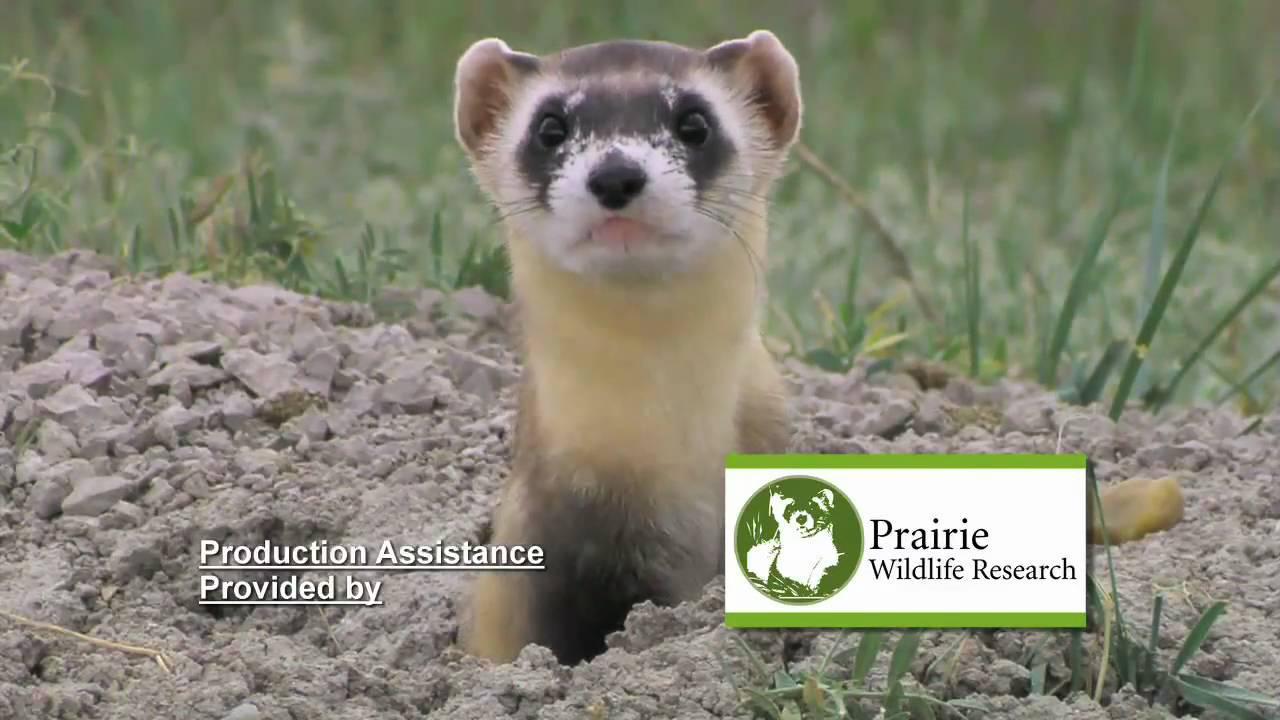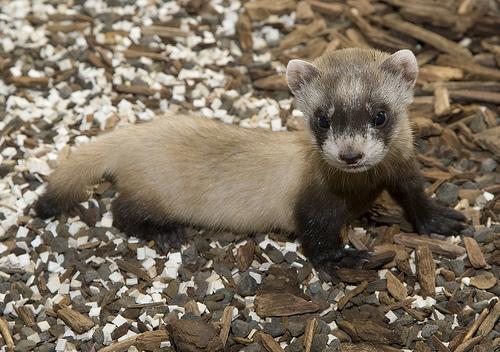The first image is the image on the left, the second image is the image on the right. For the images shown, is this caption "There are no more than three ferrets" true? Answer yes or no. Yes. The first image is the image on the left, the second image is the image on the right. Analyze the images presented: Is the assertion "The images contain a total of four ferrets." valid? Answer yes or no. No. 